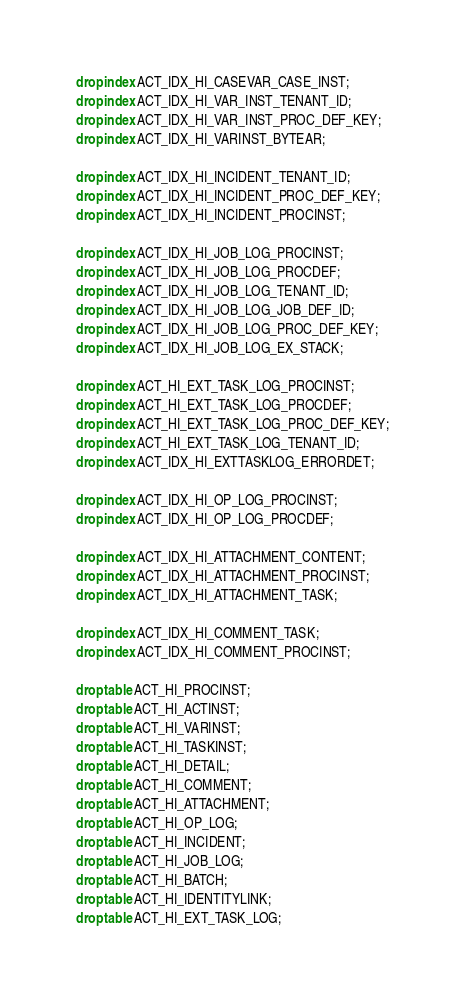<code> <loc_0><loc_0><loc_500><loc_500><_SQL_>drop index ACT_IDX_HI_CASEVAR_CASE_INST;
drop index ACT_IDX_HI_VAR_INST_TENANT_ID;
drop index ACT_IDX_HI_VAR_INST_PROC_DEF_KEY;
drop index ACT_IDX_HI_VARINST_BYTEAR;

drop index ACT_IDX_HI_INCIDENT_TENANT_ID;
drop index ACT_IDX_HI_INCIDENT_PROC_DEF_KEY;
drop index ACT_IDX_HI_INCIDENT_PROCINST;

drop index ACT_IDX_HI_JOB_LOG_PROCINST;
drop index ACT_IDX_HI_JOB_LOG_PROCDEF;
drop index ACT_IDX_HI_JOB_LOG_TENANT_ID;
drop index ACT_IDX_HI_JOB_LOG_JOB_DEF_ID;
drop index ACT_IDX_HI_JOB_LOG_PROC_DEF_KEY;
drop index ACT_IDX_HI_JOB_LOG_EX_STACK;

drop index ACT_HI_EXT_TASK_LOG_PROCINST;
drop index ACT_HI_EXT_TASK_LOG_PROCDEF;
drop index ACT_HI_EXT_TASK_LOG_PROC_DEF_KEY;
drop index ACT_HI_EXT_TASK_LOG_TENANT_ID;
drop index ACT_IDX_HI_EXTTASKLOG_ERRORDET;

drop index ACT_IDX_HI_OP_LOG_PROCINST;
drop index ACT_IDX_HI_OP_LOG_PROCDEF;

drop index ACT_IDX_HI_ATTACHMENT_CONTENT;
drop index ACT_IDX_HI_ATTACHMENT_PROCINST;
drop index ACT_IDX_HI_ATTACHMENT_TASK;

drop index ACT_IDX_HI_COMMENT_TASK;
drop index ACT_IDX_HI_COMMENT_PROCINST;

drop table ACT_HI_PROCINST;
drop table ACT_HI_ACTINST;
drop table ACT_HI_VARINST;
drop table ACT_HI_TASKINST;
drop table ACT_HI_DETAIL;
drop table ACT_HI_COMMENT;
drop table ACT_HI_ATTACHMENT;
drop table ACT_HI_OP_LOG;
drop table ACT_HI_INCIDENT;
drop table ACT_HI_JOB_LOG;
drop table ACT_HI_BATCH;
drop table ACT_HI_IDENTITYLINK;
drop table ACT_HI_EXT_TASK_LOG;</code> 